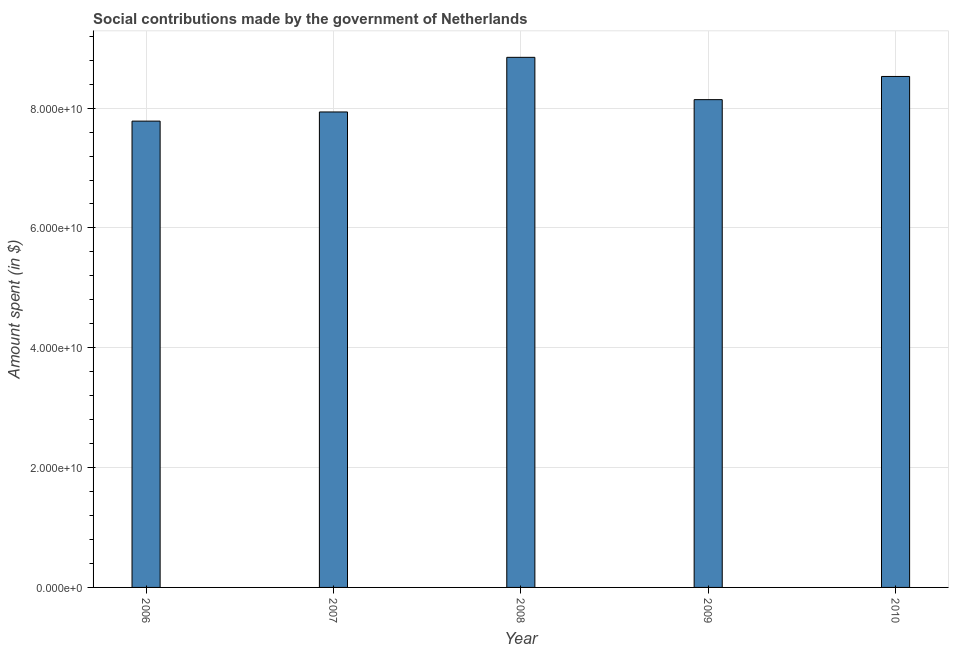Does the graph contain any zero values?
Provide a succinct answer. No. Does the graph contain grids?
Your answer should be compact. Yes. What is the title of the graph?
Provide a short and direct response. Social contributions made by the government of Netherlands. What is the label or title of the Y-axis?
Your response must be concise. Amount spent (in $). What is the amount spent in making social contributions in 2009?
Your answer should be very brief. 8.14e+1. Across all years, what is the maximum amount spent in making social contributions?
Your answer should be very brief. 8.85e+1. Across all years, what is the minimum amount spent in making social contributions?
Keep it short and to the point. 7.78e+1. In which year was the amount spent in making social contributions maximum?
Give a very brief answer. 2008. In which year was the amount spent in making social contributions minimum?
Your answer should be compact. 2006. What is the sum of the amount spent in making social contributions?
Your answer should be very brief. 4.12e+11. What is the difference between the amount spent in making social contributions in 2008 and 2010?
Provide a succinct answer. 3.19e+09. What is the average amount spent in making social contributions per year?
Offer a very short reply. 8.25e+1. What is the median amount spent in making social contributions?
Ensure brevity in your answer.  8.14e+1. Do a majority of the years between 2008 and 2009 (inclusive) have amount spent in making social contributions greater than 84000000000 $?
Your answer should be compact. No. What is the ratio of the amount spent in making social contributions in 2008 to that in 2009?
Offer a very short reply. 1.09. Is the amount spent in making social contributions in 2006 less than that in 2007?
Your answer should be very brief. Yes. Is the difference between the amount spent in making social contributions in 2006 and 2009 greater than the difference between any two years?
Make the answer very short. No. What is the difference between the highest and the second highest amount spent in making social contributions?
Your answer should be compact. 3.19e+09. Is the sum of the amount spent in making social contributions in 2007 and 2008 greater than the maximum amount spent in making social contributions across all years?
Offer a very short reply. Yes. What is the difference between the highest and the lowest amount spent in making social contributions?
Your response must be concise. 1.06e+1. In how many years, is the amount spent in making social contributions greater than the average amount spent in making social contributions taken over all years?
Offer a terse response. 2. How many years are there in the graph?
Provide a succinct answer. 5. What is the difference between two consecutive major ticks on the Y-axis?
Offer a terse response. 2.00e+1. Are the values on the major ticks of Y-axis written in scientific E-notation?
Keep it short and to the point. Yes. What is the Amount spent (in $) of 2006?
Your answer should be very brief. 7.78e+1. What is the Amount spent (in $) of 2007?
Offer a terse response. 7.94e+1. What is the Amount spent (in $) in 2008?
Offer a terse response. 8.85e+1. What is the Amount spent (in $) in 2009?
Your answer should be very brief. 8.14e+1. What is the Amount spent (in $) of 2010?
Offer a terse response. 8.53e+1. What is the difference between the Amount spent (in $) in 2006 and 2007?
Your answer should be compact. -1.53e+09. What is the difference between the Amount spent (in $) in 2006 and 2008?
Keep it short and to the point. -1.06e+1. What is the difference between the Amount spent (in $) in 2006 and 2009?
Provide a short and direct response. -3.58e+09. What is the difference between the Amount spent (in $) in 2006 and 2010?
Ensure brevity in your answer.  -7.45e+09. What is the difference between the Amount spent (in $) in 2007 and 2008?
Your answer should be very brief. -9.12e+09. What is the difference between the Amount spent (in $) in 2007 and 2009?
Make the answer very short. -2.05e+09. What is the difference between the Amount spent (in $) in 2007 and 2010?
Provide a short and direct response. -5.92e+09. What is the difference between the Amount spent (in $) in 2008 and 2009?
Your answer should be very brief. 7.06e+09. What is the difference between the Amount spent (in $) in 2008 and 2010?
Your answer should be very brief. 3.19e+09. What is the difference between the Amount spent (in $) in 2009 and 2010?
Make the answer very short. -3.87e+09. What is the ratio of the Amount spent (in $) in 2006 to that in 2008?
Offer a very short reply. 0.88. What is the ratio of the Amount spent (in $) in 2006 to that in 2009?
Ensure brevity in your answer.  0.96. What is the ratio of the Amount spent (in $) in 2007 to that in 2008?
Provide a short and direct response. 0.9. What is the ratio of the Amount spent (in $) in 2007 to that in 2010?
Provide a short and direct response. 0.93. What is the ratio of the Amount spent (in $) in 2008 to that in 2009?
Your answer should be compact. 1.09. What is the ratio of the Amount spent (in $) in 2009 to that in 2010?
Offer a very short reply. 0.95. 